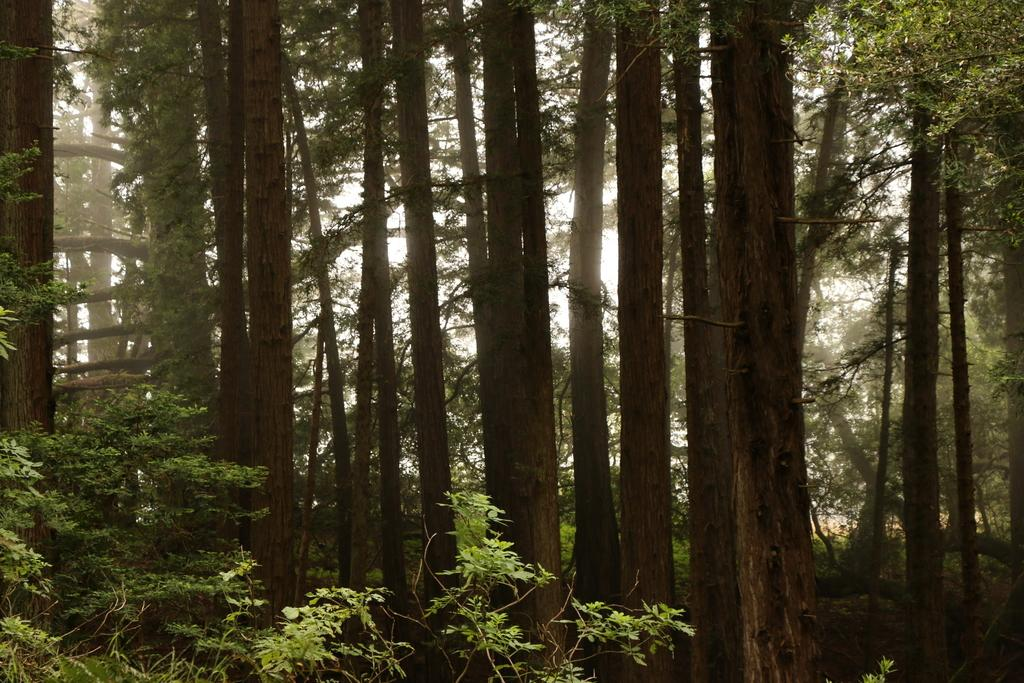What type of natural elements can be seen in the image? There are trees in the image. What is the color of the background in the image? The background of the image is white. What type of paper is hanging on the wall in the image? There is no paper or wall present in the image; it features trees and a white background. What kind of apparatus is visible in the image? There is no apparatus present in the image; it only contains trees and a white background. 